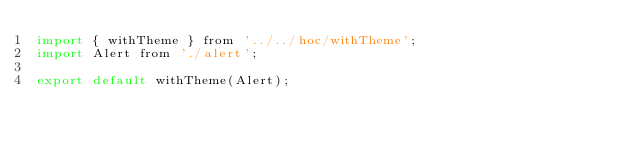Convert code to text. <code><loc_0><loc_0><loc_500><loc_500><_JavaScript_>import { withTheme } from '../../hoc/withTheme';
import Alert from './alert';

export default withTheme(Alert);
</code> 